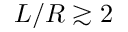<formula> <loc_0><loc_0><loc_500><loc_500>L / R \gtrsim 2</formula> 